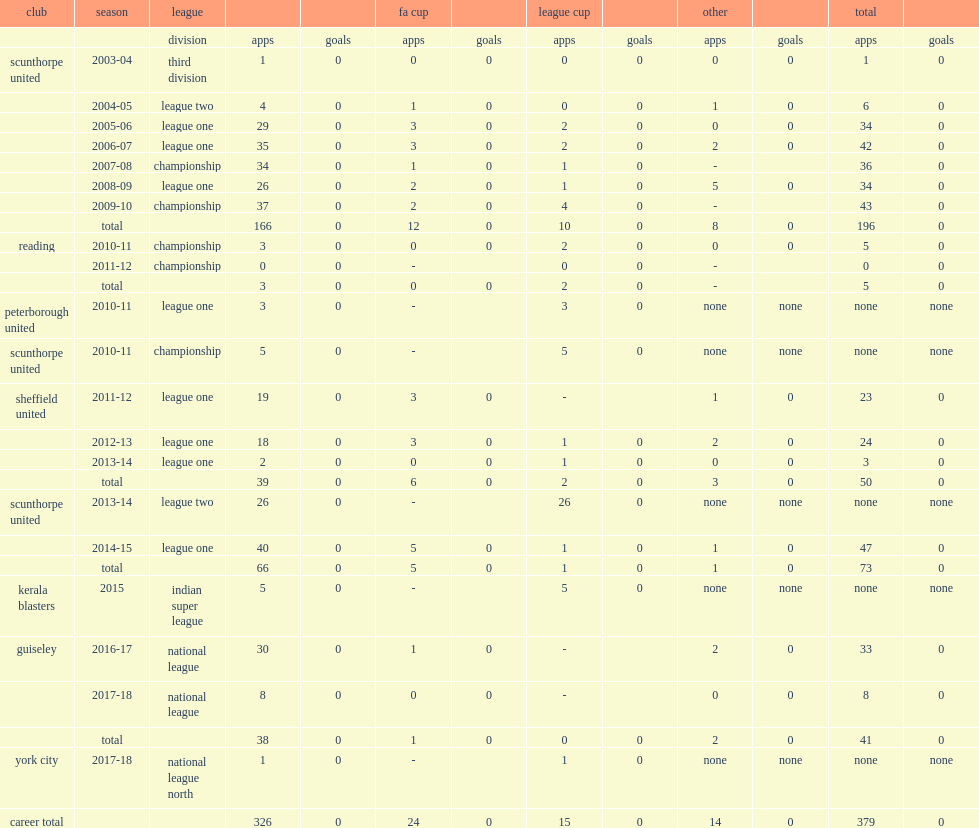Write the full table. {'header': ['club', 'season', 'league', '', '', 'fa cup', '', 'league cup', '', 'other', '', 'total', ''], 'rows': [['', '', 'division', 'apps', 'goals', 'apps', 'goals', 'apps', 'goals', 'apps', 'goals', 'apps', 'goals'], ['scunthorpe united', '2003-04', 'third division', '1', '0', '0', '0', '0', '0', '0', '0', '1', '0'], ['', '2004-05', 'league two', '4', '0', '1', '0', '0', '0', '1', '0', '6', '0'], ['', '2005-06', 'league one', '29', '0', '3', '0', '2', '0', '0', '0', '34', '0'], ['', '2006-07', 'league one', '35', '0', '3', '0', '2', '0', '2', '0', '42', '0'], ['', '2007-08', 'championship', '34', '0', '1', '0', '1', '0', '-', '', '36', '0'], ['', '2008-09', 'league one', '26', '0', '2', '0', '1', '0', '5', '0', '34', '0'], ['', '2009-10', 'championship', '37', '0', '2', '0', '4', '0', '-', '', '43', '0'], ['', 'total', '', '166', '0', '12', '0', '10', '0', '8', '0', '196', '0'], ['reading', '2010-11', 'championship', '3', '0', '0', '0', '2', '0', '0', '0', '5', '0'], ['', '2011-12', 'championship', '0', '0', '-', '', '0', '0', '-', '', '0', '0'], ['', 'total', '', '3', '0', '0', '0', '2', '0', '-', '', '5', '0'], ['peterborough united', '2010-11', 'league one', '3', '0', '-', '', '3', '0', 'none', 'none', 'none', 'none'], ['scunthorpe united', '2010-11', 'championship', '5', '0', '-', '', '5', '0', 'none', 'none', 'none', 'none'], ['sheffield united', '2011-12', 'league one', '19', '0', '3', '0', '-', '', '1', '0', '23', '0'], ['', '2012-13', 'league one', '18', '0', '3', '0', '1', '0', '2', '0', '24', '0'], ['', '2013-14', 'league one', '2', '0', '0', '0', '1', '0', '0', '0', '3', '0'], ['', 'total', '', '39', '0', '6', '0', '2', '0', '3', '0', '50', '0'], ['scunthorpe united', '2013-14', 'league two', '26', '0', '-', '', '26', '0', 'none', 'none', 'none', 'none'], ['', '2014-15', 'league one', '40', '0', '5', '0', '1', '0', '1', '0', '47', '0'], ['', 'total', '', '66', '0', '5', '0', '1', '0', '1', '0', '73', '0'], ['kerala blasters', '2015', 'indian super league', '5', '0', '-', '', '5', '0', 'none', 'none', 'none', 'none'], ['guiseley', '2016-17', 'national league', '30', '0', '1', '0', '-', '', '2', '0', '33', '0'], ['', '2017-18', 'national league', '8', '0', '0', '0', '-', '', '0', '0', '8', '0'], ['', 'total', '', '38', '0', '1', '0', '0', '0', '2', '0', '41', '0'], ['york city', '2017-18', 'national league north', '1', '0', '-', '', '1', '0', 'none', 'none', 'none', 'none'], ['career total', '', '', '326', '0', '24', '0', '15', '0', '14', '0', '379', '0']]} In 2015, which league did williams sign for club kerala blasters? Indian super league. 